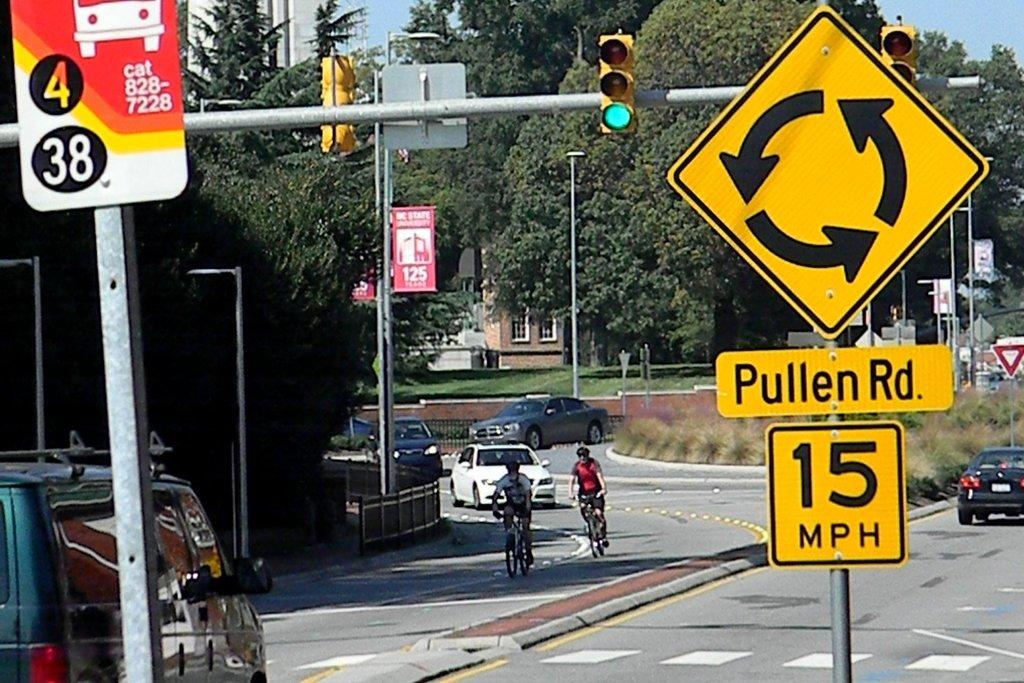Provide a one-sentence caption for the provided image. People ride bicycles near a traffic sign with a 15 mile per hour speed limit. 